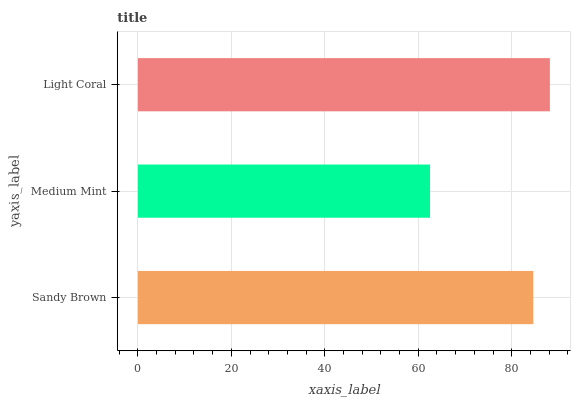Is Medium Mint the minimum?
Answer yes or no. Yes. Is Light Coral the maximum?
Answer yes or no. Yes. Is Light Coral the minimum?
Answer yes or no. No. Is Medium Mint the maximum?
Answer yes or no. No. Is Light Coral greater than Medium Mint?
Answer yes or no. Yes. Is Medium Mint less than Light Coral?
Answer yes or no. Yes. Is Medium Mint greater than Light Coral?
Answer yes or no. No. Is Light Coral less than Medium Mint?
Answer yes or no. No. Is Sandy Brown the high median?
Answer yes or no. Yes. Is Sandy Brown the low median?
Answer yes or no. Yes. Is Medium Mint the high median?
Answer yes or no. No. Is Light Coral the low median?
Answer yes or no. No. 